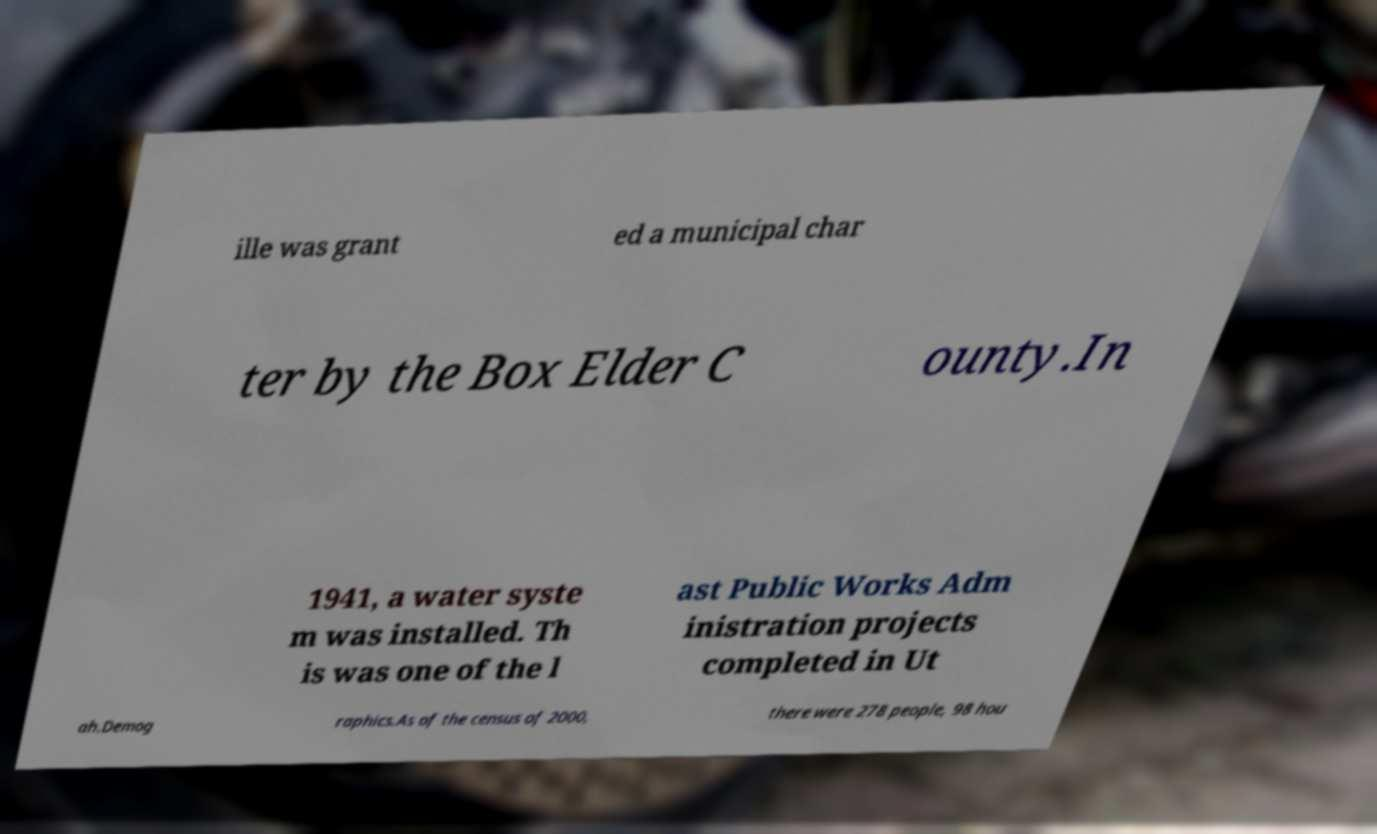I need the written content from this picture converted into text. Can you do that? ille was grant ed a municipal char ter by the Box Elder C ounty.In 1941, a water syste m was installed. Th is was one of the l ast Public Works Adm inistration projects completed in Ut ah.Demog raphics.As of the census of 2000, there were 278 people, 98 hou 